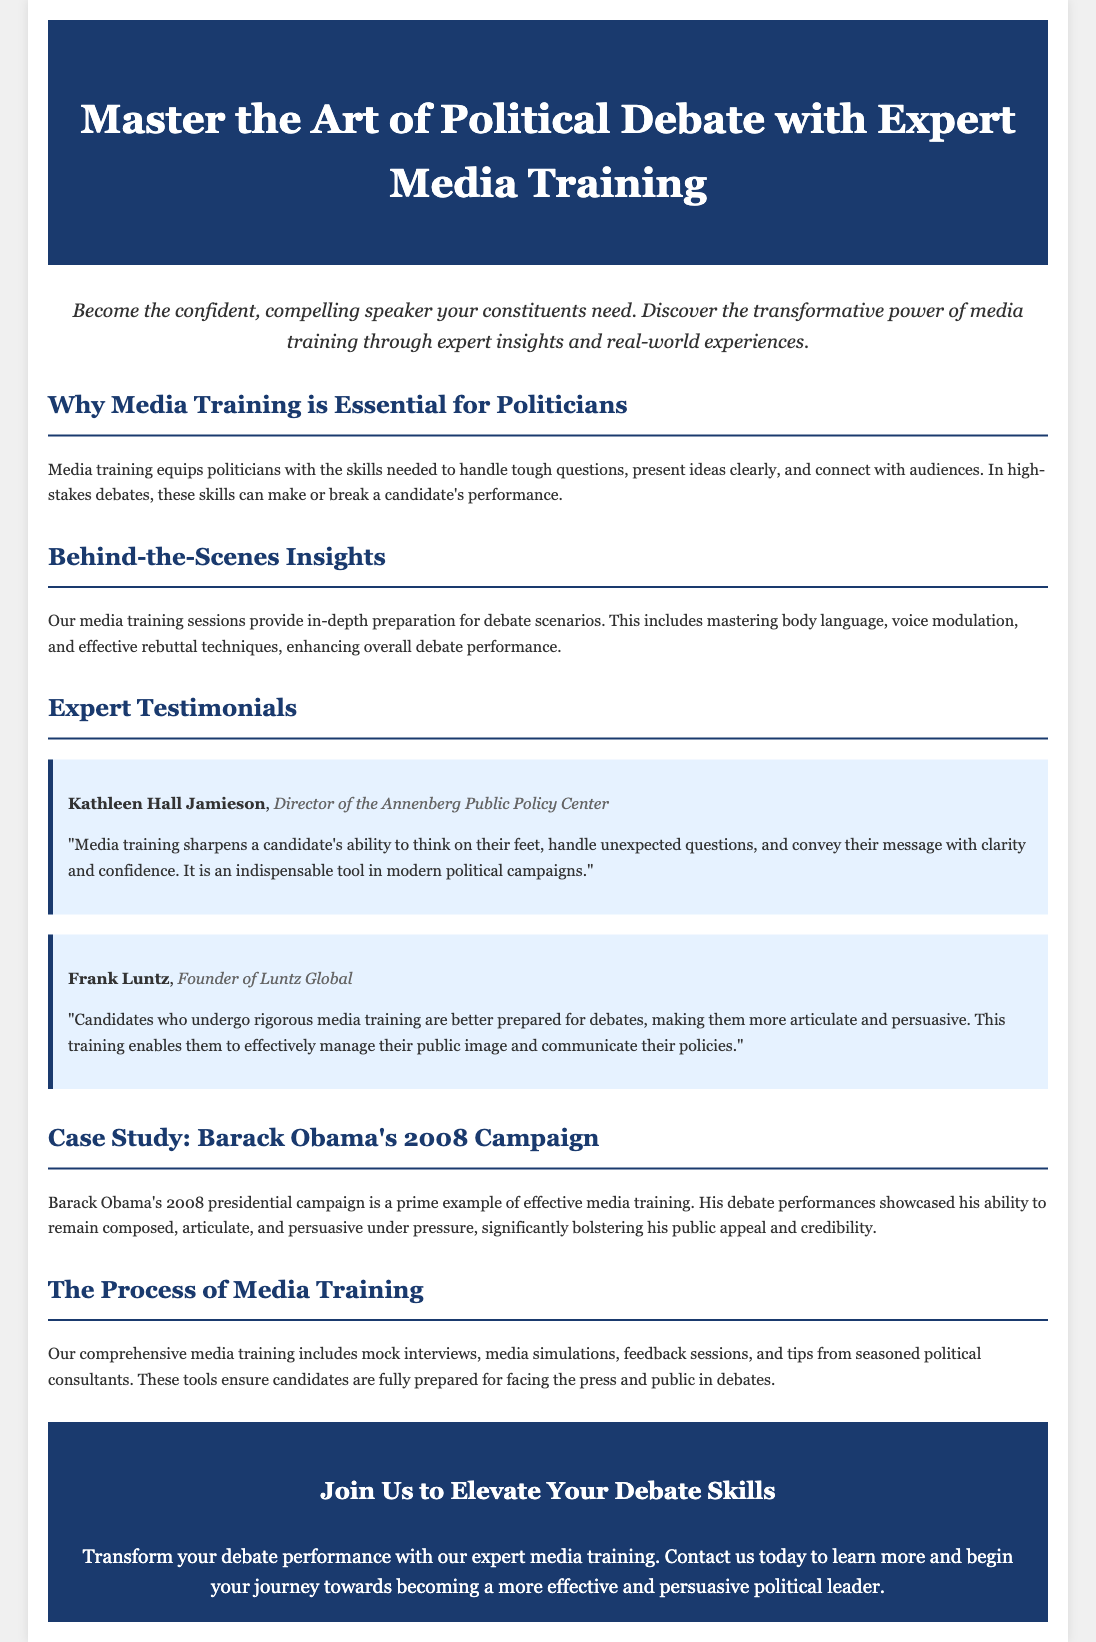What is the title of the advertisement? The title of the advertisement is prominently displayed in the header, indicating its purpose.
Answer: Master the Art of Political Debate with Expert Media Training Who is the Director of the Annenberg Public Policy Center? The document includes a testimonial from a notable expert, indicating their role.
Answer: Kathleen Hall Jamieson What is one key focus of media training according to the document? The document outlines specific skills that media training helps politicians develop.
Answer: Handle tough questions What year was Barack Obama's presidential campaign highlighted? The document refers to a specific event in a section discussing case studies.
Answer: 2008 What type of training does the advertisement mention for preparation? The document lists specific training techniques used to enhance debate performance.
Answer: Mock interviews What color is used for the section headers in the advertisement? The document describes the color scheme used throughout to enhance readability and impact.
Answer: Dark blue What does Frank Luntz reference as a benefit of media training? The document includes testimonials that describe advantages associated with media training for candidates.
Answer: Better prepared How does the advertisement suggest candidates can transform their debate skills? The document provides a call to action that encourages engagement with the offered services.
Answer: Expert media training 